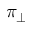<formula> <loc_0><loc_0><loc_500><loc_500>\pi _ { \perp }</formula> 